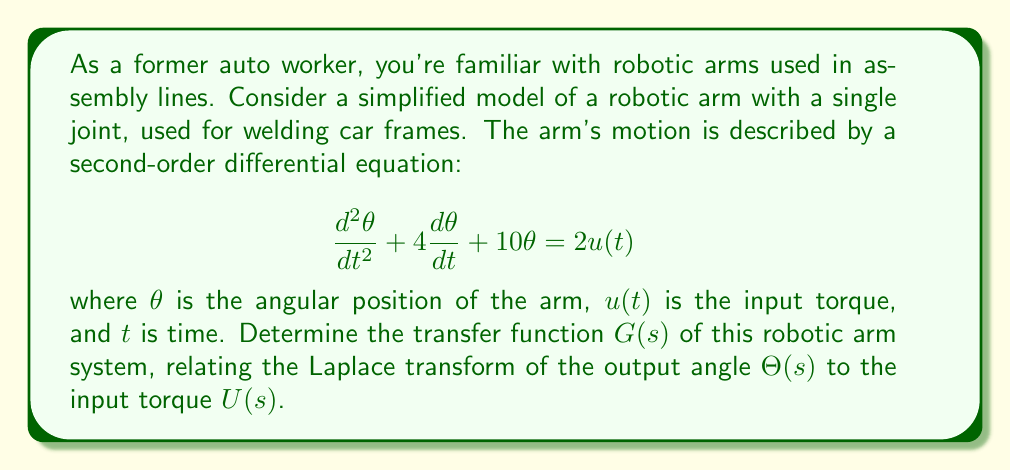Provide a solution to this math problem. To find the transfer function, we'll follow these steps:

1) First, we need to take the Laplace transform of both sides of the given differential equation. Assume zero initial conditions.

   $$s^2\Theta(s) + 4s\Theta(s) + 10\Theta(s) = 2U(s)$$

2) Factor out $\Theta(s)$ on the left side:

   $$(s^2 + 4s + 10)\Theta(s) = 2U(s)$$

3) The transfer function $G(s)$ is defined as the ratio of output to input in the s-domain:

   $$G(s) = \frac{\Theta(s)}{U(s)}$$

4) From step 2, we can write:

   $$\Theta(s) = \frac{2U(s)}{s^2 + 4s + 10}$$

5) Therefore, the transfer function is:

   $$G(s) = \frac{\Theta(s)}{U(s)} = \frac{2}{s^2 + 4s + 10}$$

This transfer function represents how the robotic arm responds to input torques in the frequency domain. It's a second-order system, which is typical for a single-joint robotic arm with inertia and damping.
Answer: $$G(s) = \frac{2}{s^2 + 4s + 10}$$ 